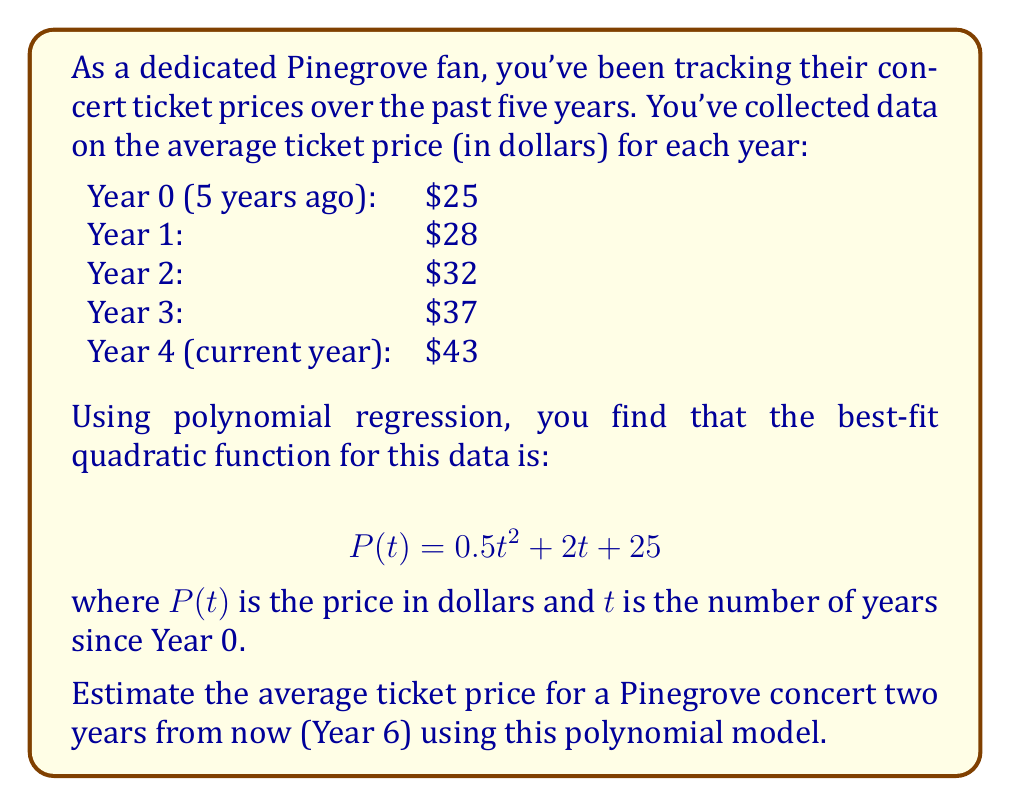Can you solve this math problem? To solve this problem, we'll follow these steps:

1. Understand the given polynomial function:
   $$ P(t) = 0.5t^2 + 2t + 25 $$
   This quadratic function models the ticket price $P$ in terms of years $t$ since Year 0.

2. Identify the year we're interested in:
   We want to estimate the price two years from now, which is Year 6 (since we're currently in Year 4).

3. Substitute $t = 6$ into the polynomial function:
   $$ P(6) = 0.5(6)^2 + 2(6) + 25 $$

4. Evaluate the expression:
   $$ P(6) = 0.5(36) + 12 + 25 $$
   $$ P(6) = 18 + 12 + 25 $$
   $$ P(6) = 55 $$

Therefore, using this polynomial regression model, we estimate that the average ticket price for a Pinegrove concert two years from now will be $55.
Answer: $55 